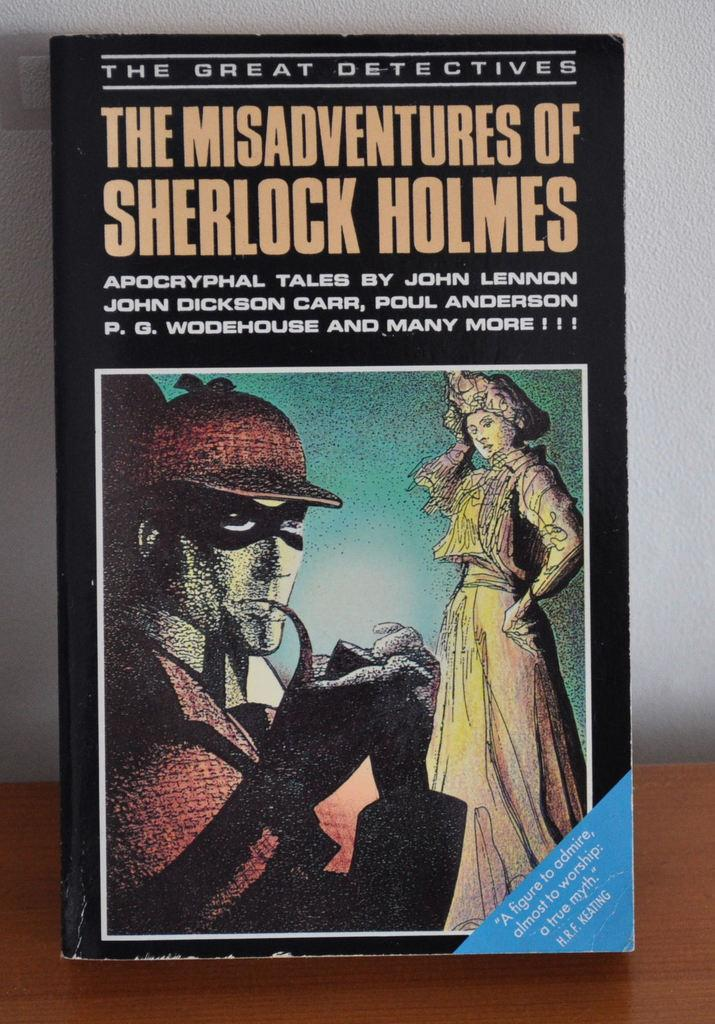Provide a one-sentence caption for the provided image. The Misadventures of Sherlock Holmes is standing up on a table. 